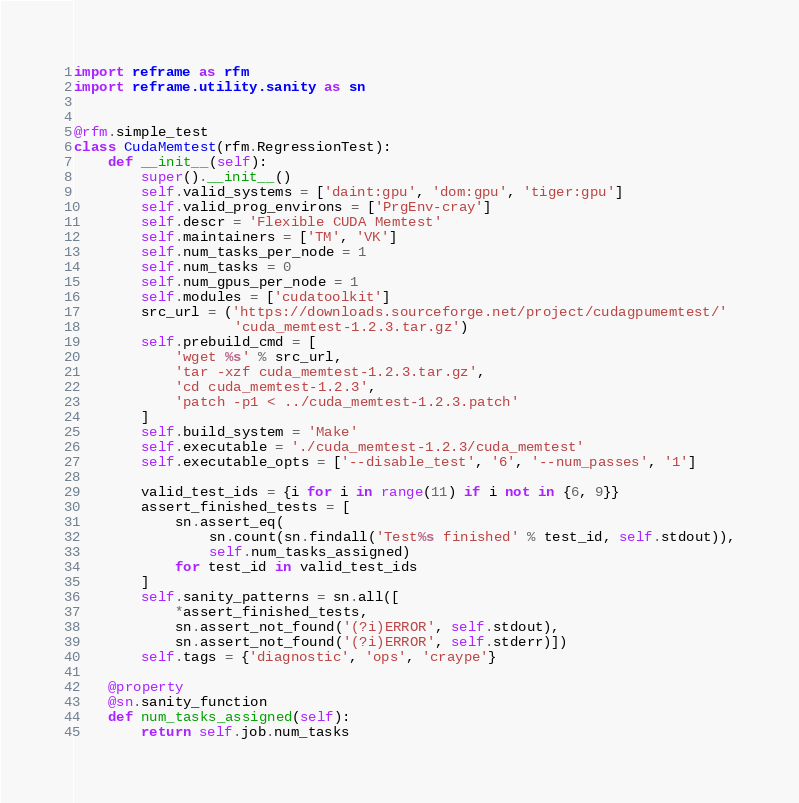<code> <loc_0><loc_0><loc_500><loc_500><_Python_>import reframe as rfm
import reframe.utility.sanity as sn


@rfm.simple_test
class CudaMemtest(rfm.RegressionTest):
    def __init__(self):
        super().__init__()
        self.valid_systems = ['daint:gpu', 'dom:gpu', 'tiger:gpu']
        self.valid_prog_environs = ['PrgEnv-cray']
        self.descr = 'Flexible CUDA Memtest'
        self.maintainers = ['TM', 'VK']
        self.num_tasks_per_node = 1
        self.num_tasks = 0
        self.num_gpus_per_node = 1
        self.modules = ['cudatoolkit']
        src_url = ('https://downloads.sourceforge.net/project/cudagpumemtest/'
                   'cuda_memtest-1.2.3.tar.gz')
        self.prebuild_cmd = [
            'wget %s' % src_url,
            'tar -xzf cuda_memtest-1.2.3.tar.gz',
            'cd cuda_memtest-1.2.3',
            'patch -p1 < ../cuda_memtest-1.2.3.patch'
        ]
        self.build_system = 'Make'
        self.executable = './cuda_memtest-1.2.3/cuda_memtest'
        self.executable_opts = ['--disable_test', '6', '--num_passes', '1']

        valid_test_ids = {i for i in range(11) if i not in {6, 9}}
        assert_finished_tests = [
            sn.assert_eq(
                sn.count(sn.findall('Test%s finished' % test_id, self.stdout)),
                self.num_tasks_assigned)
            for test_id in valid_test_ids
        ]
        self.sanity_patterns = sn.all([
            *assert_finished_tests,
            sn.assert_not_found('(?i)ERROR', self.stdout),
            sn.assert_not_found('(?i)ERROR', self.stderr)])
        self.tags = {'diagnostic', 'ops', 'craype'}

    @property
    @sn.sanity_function
    def num_tasks_assigned(self):
        return self.job.num_tasks
</code> 